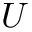<formula> <loc_0><loc_0><loc_500><loc_500>U</formula> 